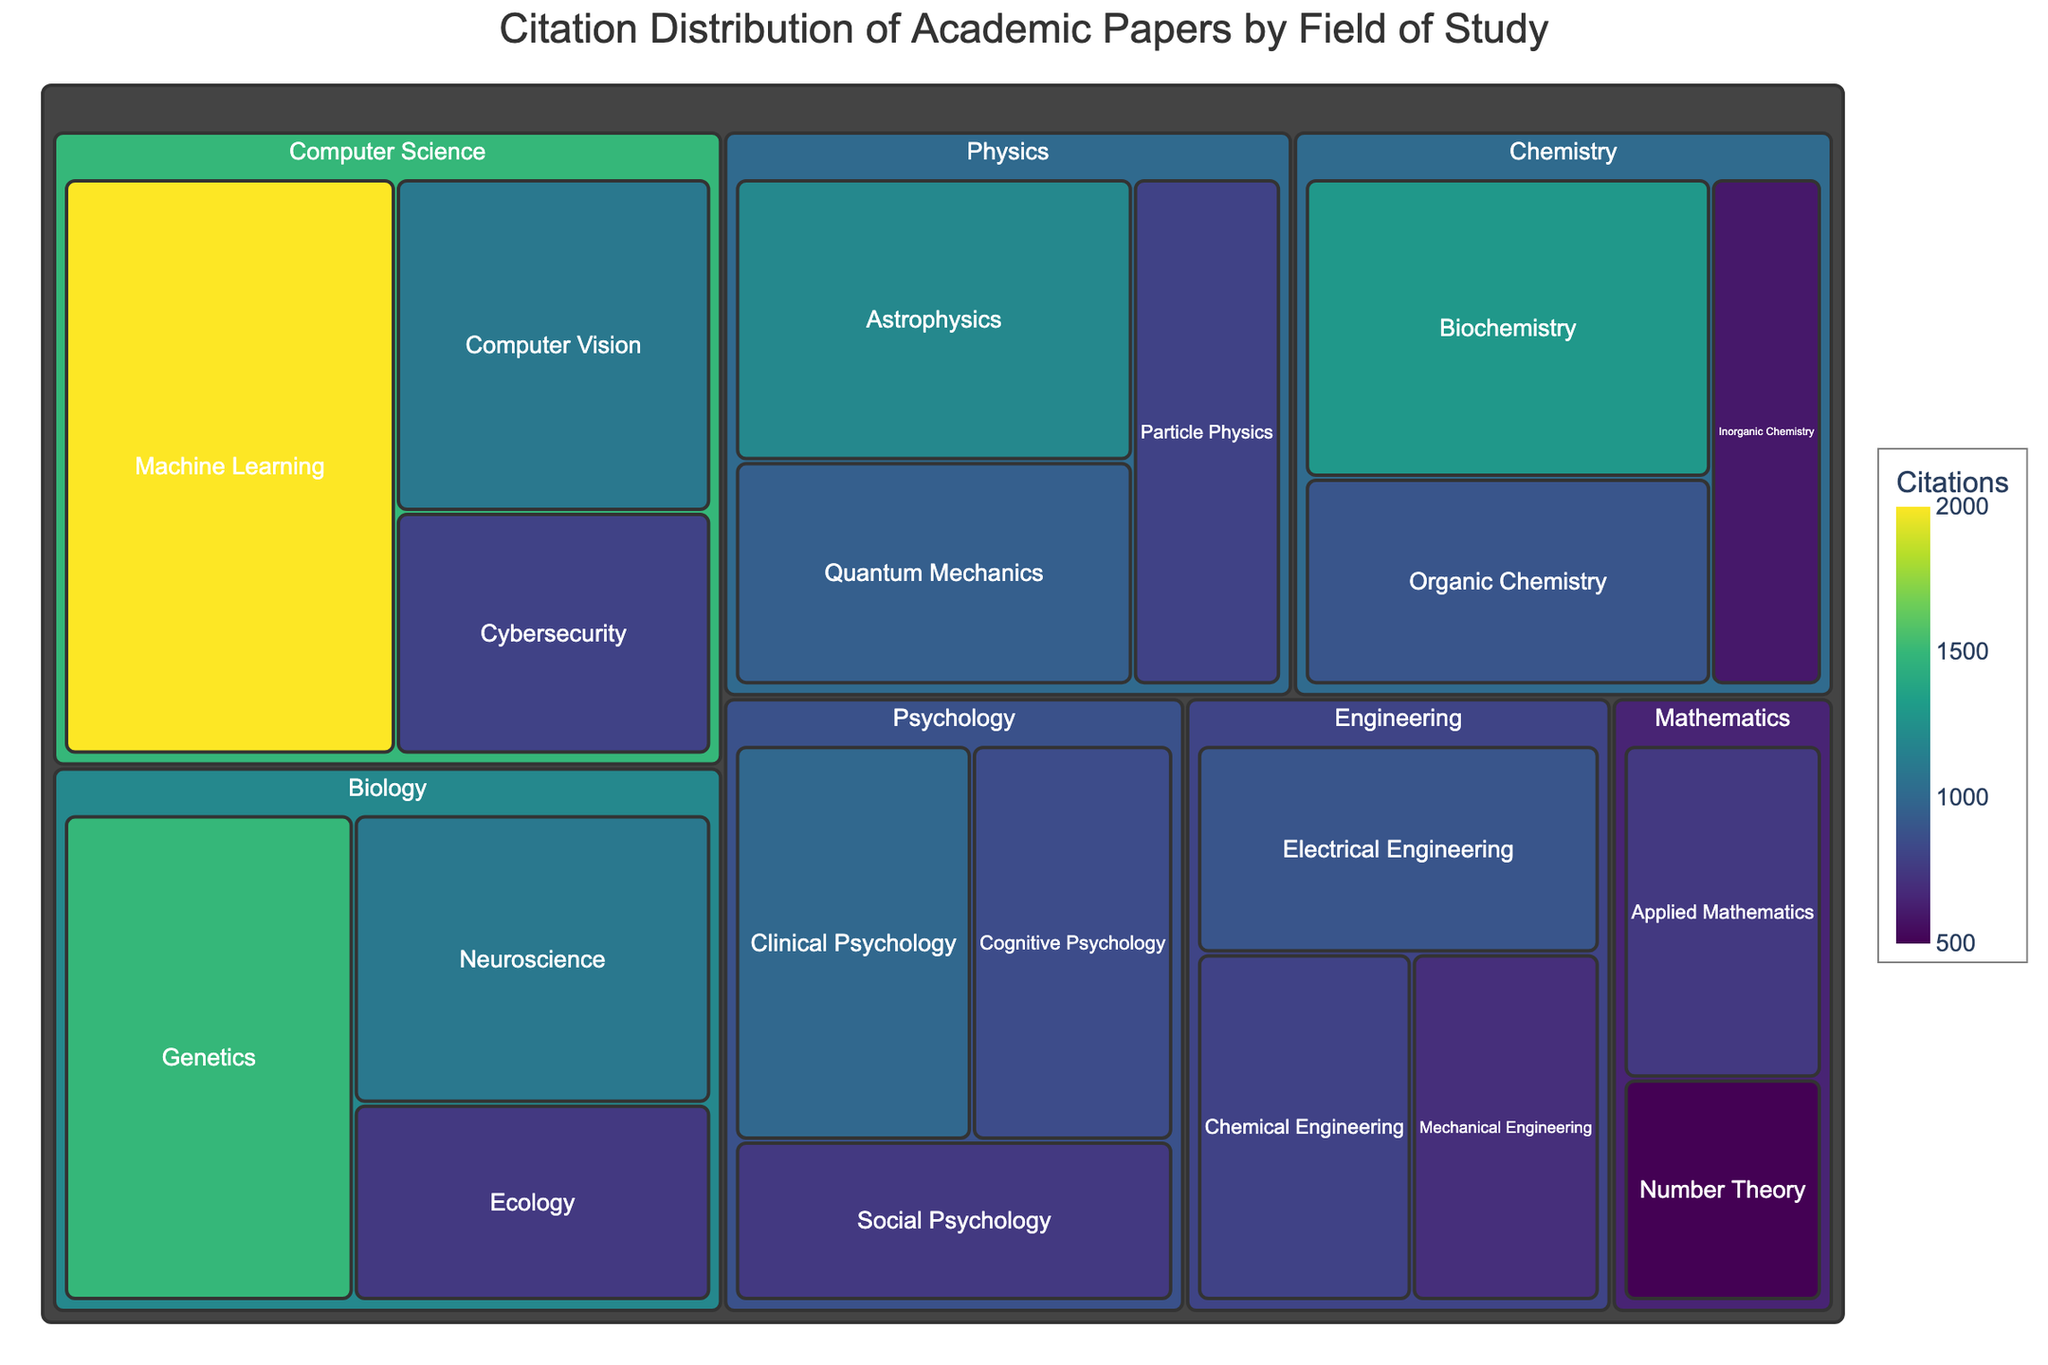What is the title of the treemap? The title of a figure is usually prominently displayed at the top. In this case, it provides a general description of the contents of the treemap.
Answer: Citation Distribution of Academic Papers by Field of Study Which subfield has the highest number of citations? To find the subfield with the highest number of citations, locate the largest tile in the treemap, which is usually the one highlighted with brighter colors.
Answer: Machine Learning How many subfields are there within the Physics field? To determine the number of subfields within Physics, count the individual tiles that are nested within the Physics tile.
Answer: Three What's the sum of citations for all Psychology subfields? Add the number of citations of each subfield within Psychology (Clinical Psychology + Cognitive Psychology + Social Psychology): 1000 + 850 + 750.
Answer: 2600 Which field has the most subfields with citations reported? This involves counting the number of subfields (tiles) within each field (larger tiles), and identifying the field with the highest count.
Answer: Biology What is the approximate difference in citations between Astrophysics and Neuroscience? Subtract the number of citations for Astrophysics from those for Neuroscience: (1100 - 1200).
Answer: -100 Which subfield in Chemistry has fewer citations, Organic Chemistry or Inorganic Chemistry? Compare the number of citations between Organic Chemistry and Inorganic Chemistry within the Chemistry field.
Answer: Inorganic Chemistry How is the field of Mathematics depicted compared to Engineering in terms of subfield citations? Compare the size and color of the tiles representing subfields of Mathematics to those in Engineering by observing the visual representation of citation counts.
Answer: Mathematics has two subfields with lower citations both in count and size compared to Engineering’s subfields From which field does the subfield with the smallest number of citations belong? Identify the smallest tile in the treemap and observe which field it falls under.
Answer: Mathematics (Number Theory) What proportion of total citations does the field of Computer Science have? To determine the proportion, sum up the citations for all subfields in Computer Science and divide by the total citations for all fields, then multiply by 100 to get the percentage. This involves calculating the total citations as: 1200 + 950 + 800 + 1500 + 750 + 1100 + 900 + 1300 + 600 + 2000 + 1100 + 800 + 1000 + 850 + 750 + 700 + 900 + 800 + 500 + 750 = 20200. For Computer Science: 2000 + 1100 + 800 = 3900.
Answer: 19.31% 